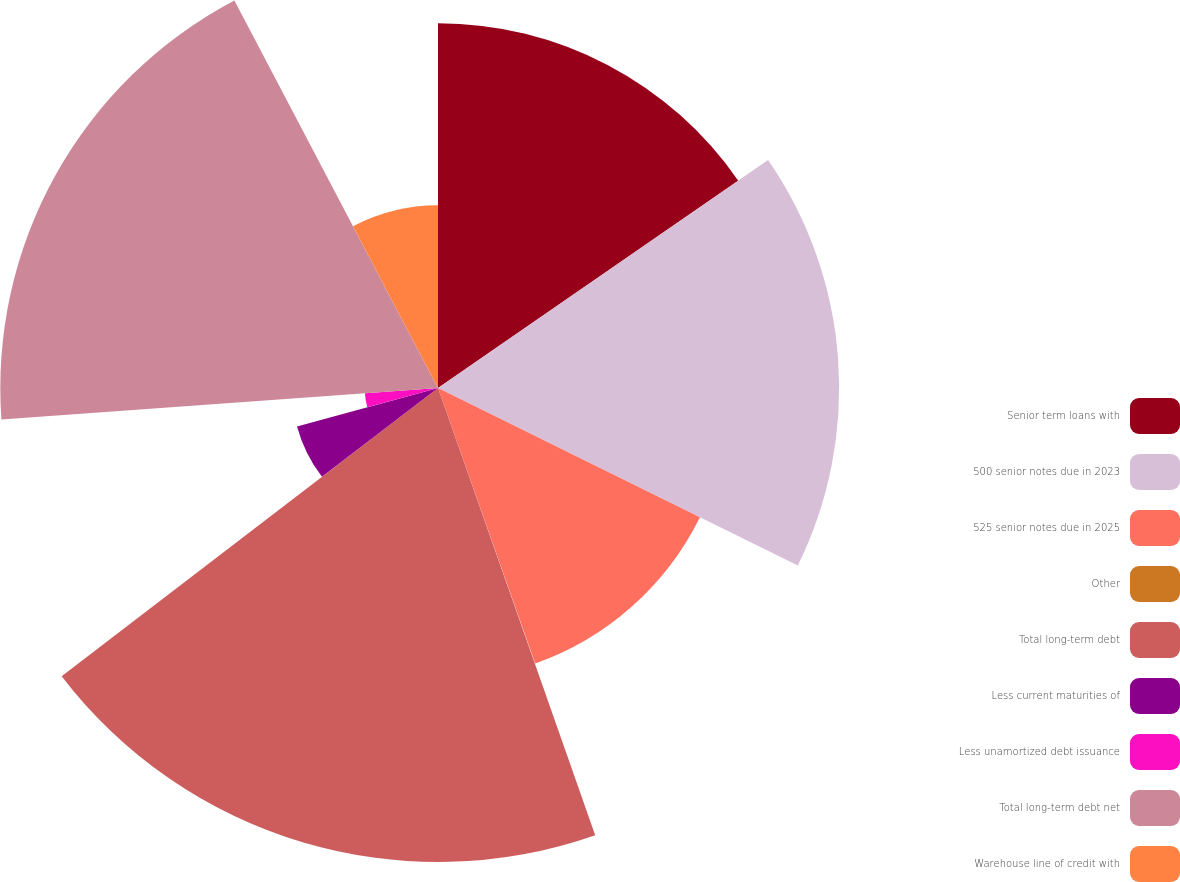Convert chart. <chart><loc_0><loc_0><loc_500><loc_500><pie_chart><fcel>Senior term loans with<fcel>500 senior notes due in 2023<fcel>525 senior notes due in 2025<fcel>Other<fcel>Total long-term debt<fcel>Less current maturities of<fcel>Less unamortized debt issuance<fcel>Total long-term debt net<fcel>Warehouse line of credit with<nl><fcel>15.38%<fcel>16.91%<fcel>12.31%<fcel>0.02%<fcel>19.98%<fcel>6.16%<fcel>3.09%<fcel>18.45%<fcel>7.7%<nl></chart> 